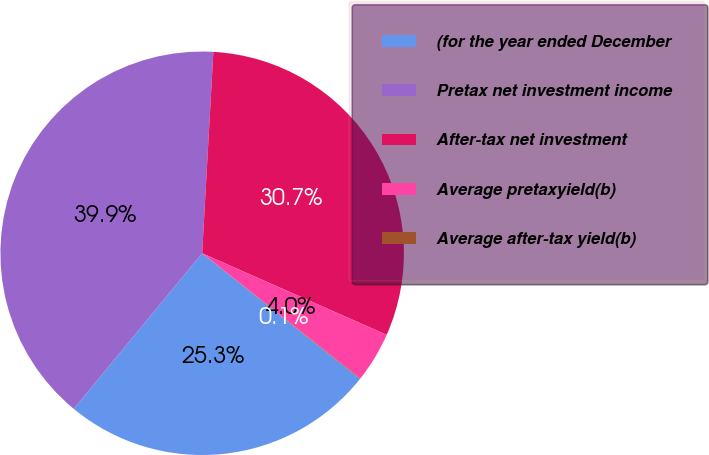<chart> <loc_0><loc_0><loc_500><loc_500><pie_chart><fcel>(for the year ended December<fcel>Pretax net investment income<fcel>After-tax net investment<fcel>Average pretaxyield(b)<fcel>Average after-tax yield(b)<nl><fcel>25.28%<fcel>39.9%<fcel>30.74%<fcel>4.03%<fcel>0.05%<nl></chart> 